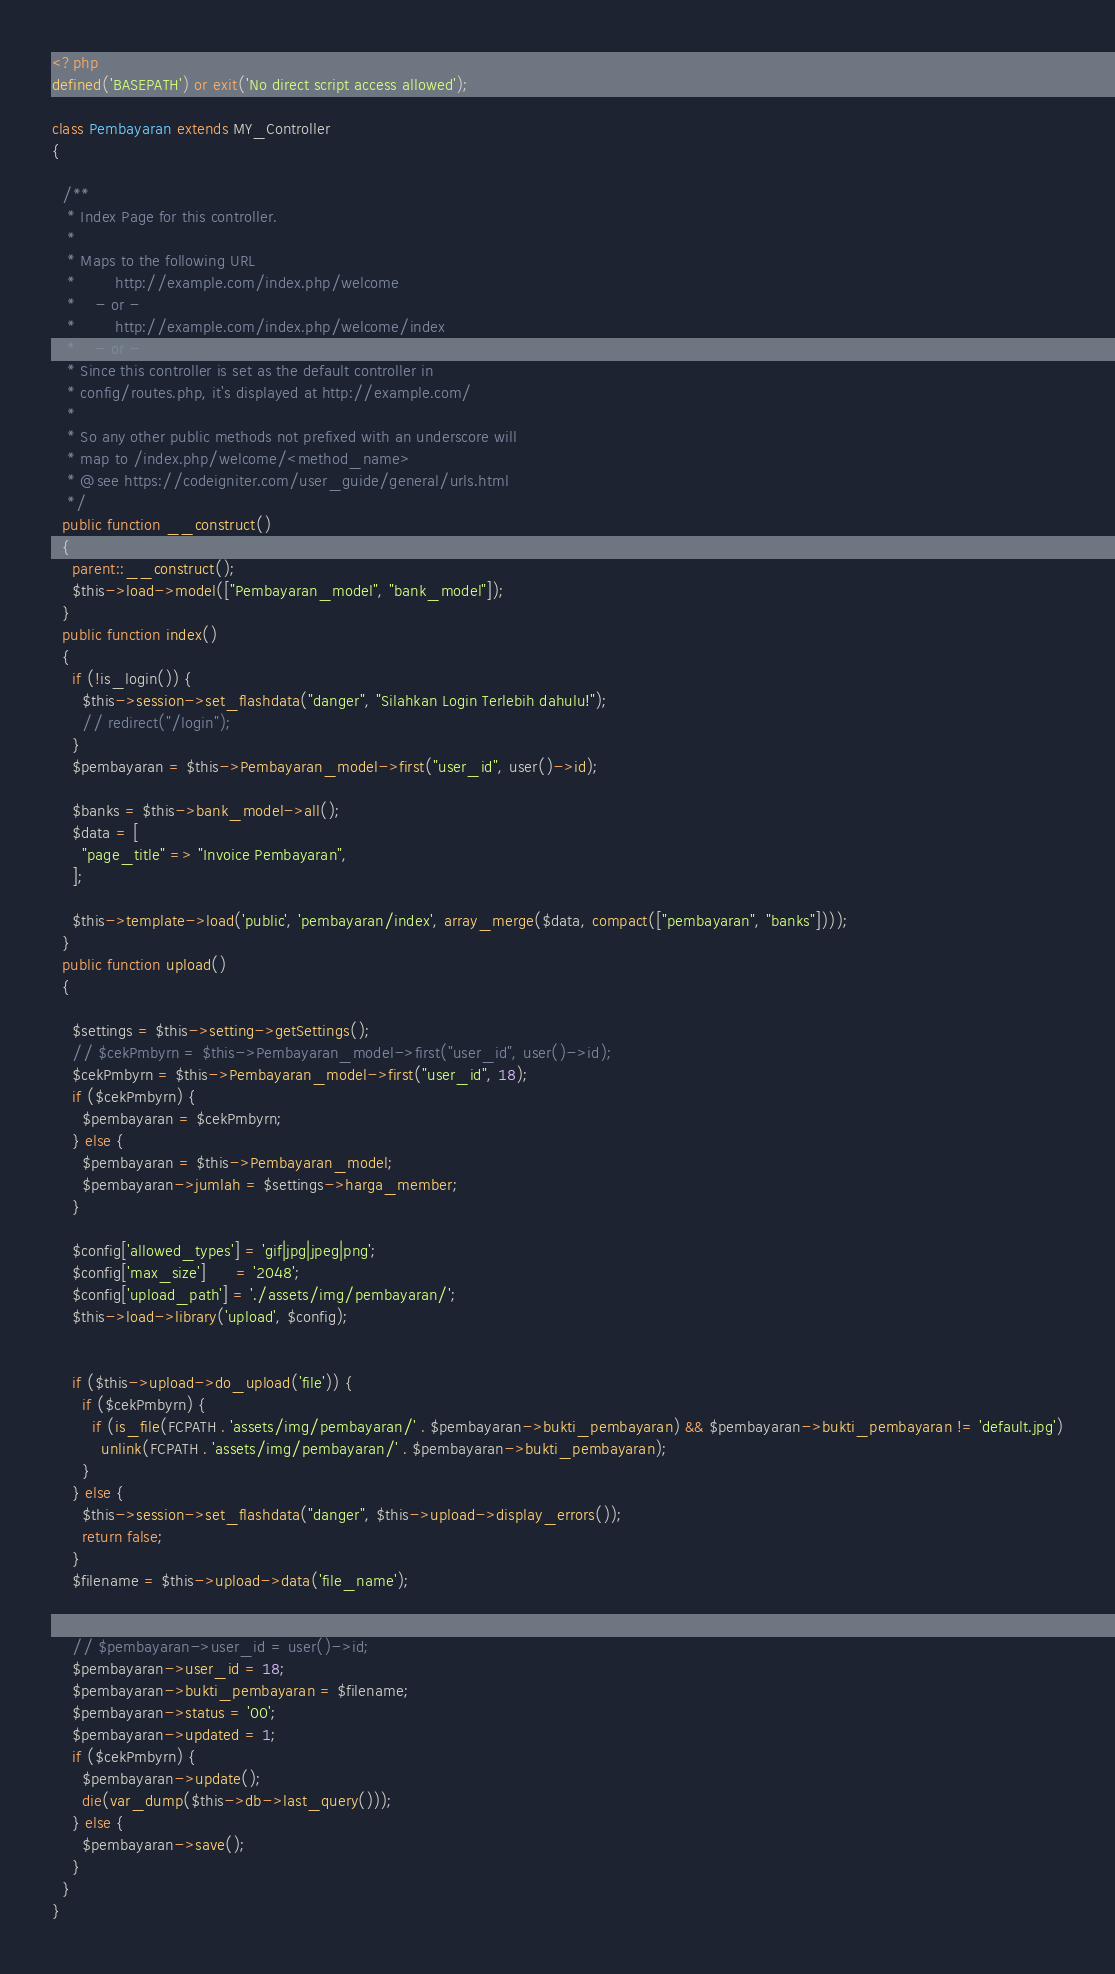Convert code to text. <code><loc_0><loc_0><loc_500><loc_500><_PHP_><?php
defined('BASEPATH') or exit('No direct script access allowed');

class Pembayaran extends MY_Controller
{

  /**
   * Index Page for this controller.
   *
   * Maps to the following URL
   * 		http://example.com/index.php/welcome
   *	- or -
   * 		http://example.com/index.php/welcome/index
   *	- or -
   * Since this controller is set as the default controller in
   * config/routes.php, it's displayed at http://example.com/
   *
   * So any other public methods not prefixed with an underscore will
   * map to /index.php/welcome/<method_name>
   * @see https://codeigniter.com/user_guide/general/urls.html
   */
  public function __construct()
  {
    parent::__construct();
    $this->load->model(["Pembayaran_model", "bank_model"]);
  }
  public function index()
  {
    if (!is_login()) {
      $this->session->set_flashdata("danger", "Silahkan Login Terlebih dahulu!");
      // redirect("/login");
    }
    $pembayaran = $this->Pembayaran_model->first("user_id", user()->id);

    $banks = $this->bank_model->all();
    $data = [
      "page_title" => "Invoice Pembayaran",
    ];

    $this->template->load('public', 'pembayaran/index', array_merge($data, compact(["pembayaran", "banks"])));
  }
  public function upload()
  {

    $settings = $this->setting->getSettings();
    // $cekPmbyrn = $this->Pembayaran_model->first("user_id", user()->id);
    $cekPmbyrn = $this->Pembayaran_model->first("user_id", 18);
    if ($cekPmbyrn) {
      $pembayaran = $cekPmbyrn;
    } else {
      $pembayaran = $this->Pembayaran_model;
      $pembayaran->jumlah = $settings->harga_member;
    }

    $config['allowed_types'] = 'gif|jpg|jpeg|png';
    $config['max_size']      = '2048';
    $config['upload_path'] = './assets/img/pembayaran/';
    $this->load->library('upload', $config);


    if ($this->upload->do_upload('file')) {
      if ($cekPmbyrn) {
        if (is_file(FCPATH . 'assets/img/pembayaran/' . $pembayaran->bukti_pembayaran) && $pembayaran->bukti_pembayaran != 'default.jpg')
          unlink(FCPATH . 'assets/img/pembayaran/' . $pembayaran->bukti_pembayaran);
      }
    } else {
      $this->session->set_flashdata("danger", $this->upload->display_errors());
      return false;
    }
    $filename = $this->upload->data('file_name');


    // $pembayaran->user_id = user()->id;
    $pembayaran->user_id = 18;
    $pembayaran->bukti_pembayaran = $filename;
    $pembayaran->status = '00';
    $pembayaran->updated = 1;
    if ($cekPmbyrn) {
      $pembayaran->update();
      die(var_dump($this->db->last_query()));
    } else {
      $pembayaran->save();
    }
  }
}
</code> 